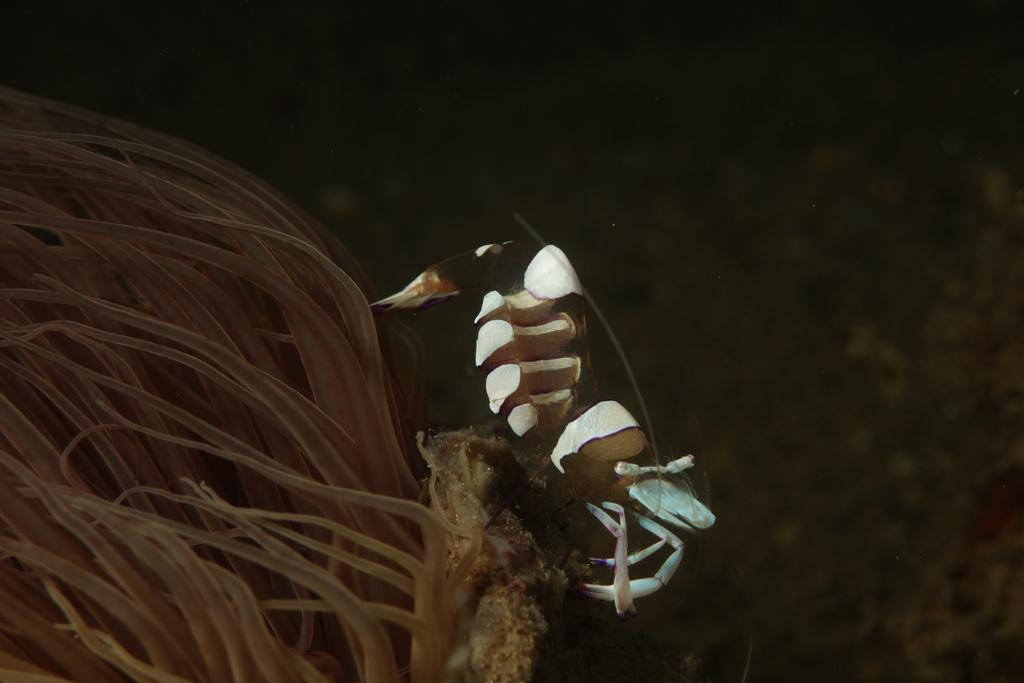What type of animal can be seen in the image? There is a marine animal in the image. What type of root can be seen growing in the image? There is no root present in the image; it features a marine animal. What type of heart can be seen beating in the image? There is no heart present in the image; it features a marine animal. 